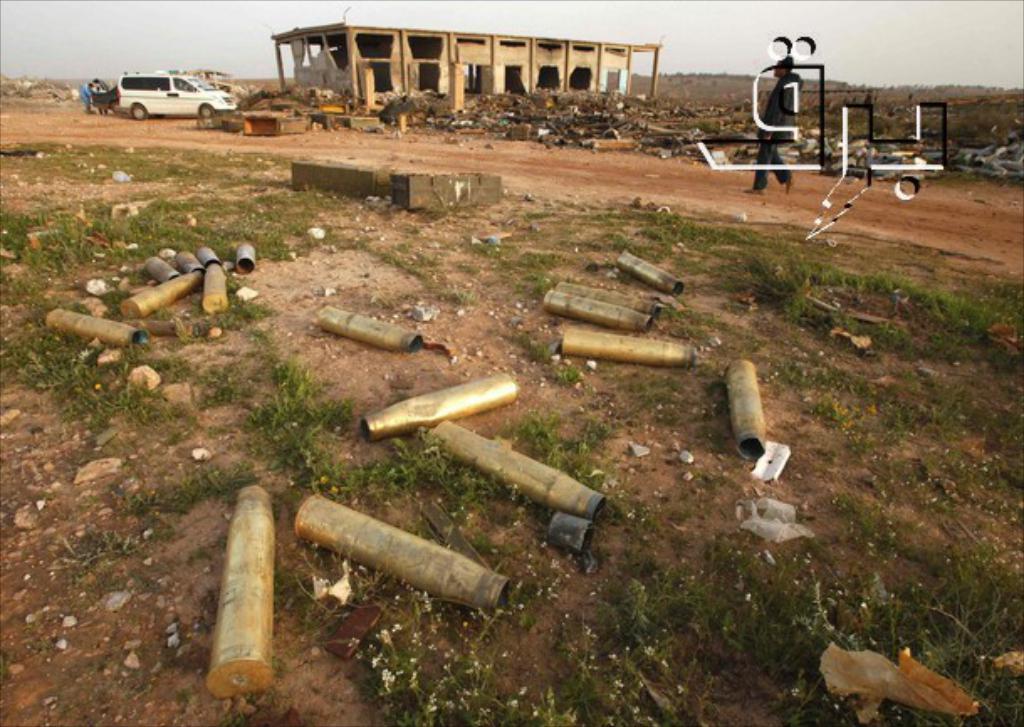Describe this image in one or two sentences. In this picture, on the right side, we can see a man walking on the land. On the left side, we can also see a car, we can also see a group of people. In the background, we can see a building which is under the construction, few trees and plants. On the top, we can see a sky, at the bottom there are some bottles on the land. 